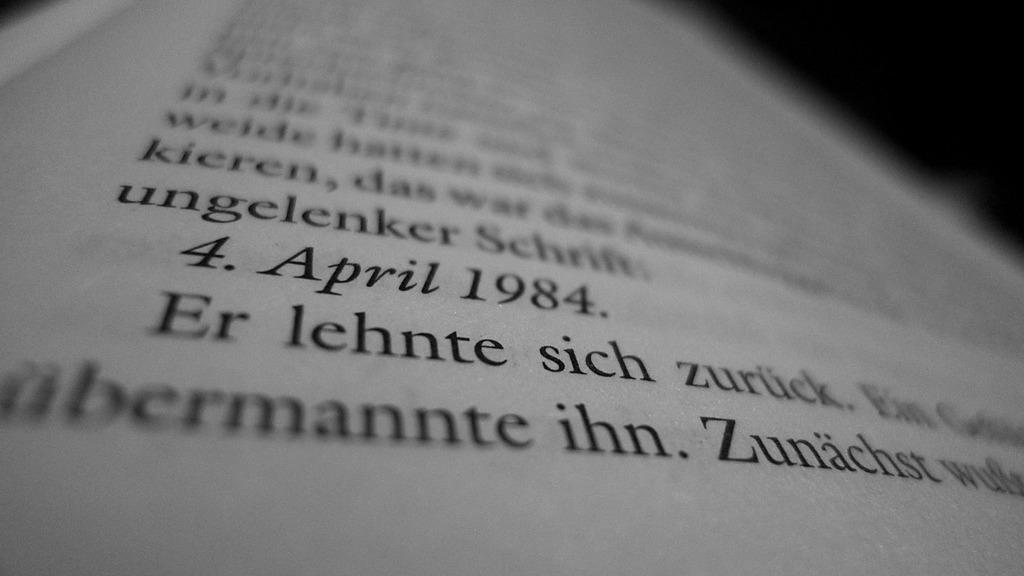<image>
Write a terse but informative summary of the picture. The date in a page of a book is April 1984. 